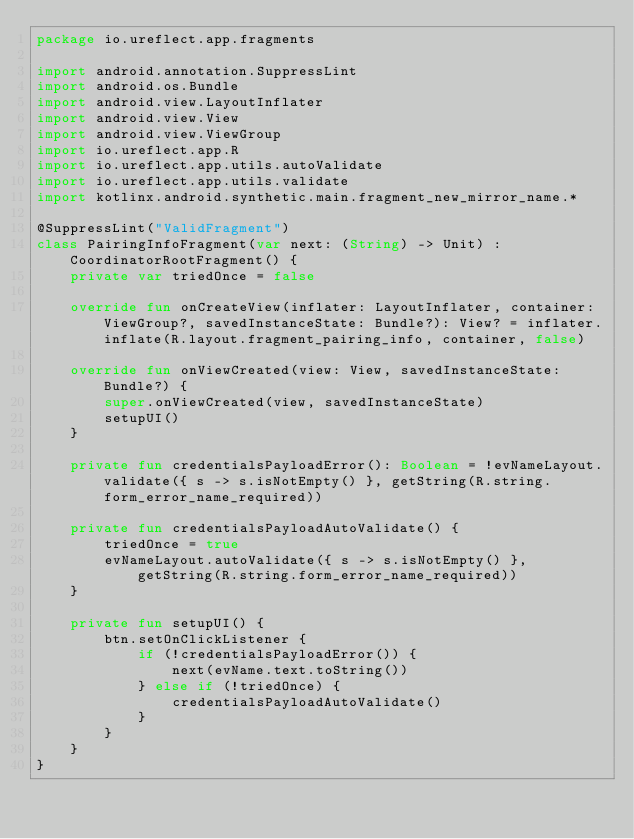Convert code to text. <code><loc_0><loc_0><loc_500><loc_500><_Kotlin_>package io.ureflect.app.fragments

import android.annotation.SuppressLint
import android.os.Bundle
import android.view.LayoutInflater
import android.view.View
import android.view.ViewGroup
import io.ureflect.app.R
import io.ureflect.app.utils.autoValidate
import io.ureflect.app.utils.validate
import kotlinx.android.synthetic.main.fragment_new_mirror_name.*

@SuppressLint("ValidFragment")
class PairingInfoFragment(var next: (String) -> Unit) : CoordinatorRootFragment() {
    private var triedOnce = false

    override fun onCreateView(inflater: LayoutInflater, container: ViewGroup?, savedInstanceState: Bundle?): View? = inflater.inflate(R.layout.fragment_pairing_info, container, false)

    override fun onViewCreated(view: View, savedInstanceState: Bundle?) {
        super.onViewCreated(view, savedInstanceState)
        setupUI()
    }

    private fun credentialsPayloadError(): Boolean = !evNameLayout.validate({ s -> s.isNotEmpty() }, getString(R.string.form_error_name_required))

    private fun credentialsPayloadAutoValidate() {
        triedOnce = true
        evNameLayout.autoValidate({ s -> s.isNotEmpty() }, getString(R.string.form_error_name_required))
    }

    private fun setupUI() {
        btn.setOnClickListener {
            if (!credentialsPayloadError()) {
                next(evName.text.toString())
            } else if (!triedOnce) {
                credentialsPayloadAutoValidate()
            }
        }
    }
}</code> 